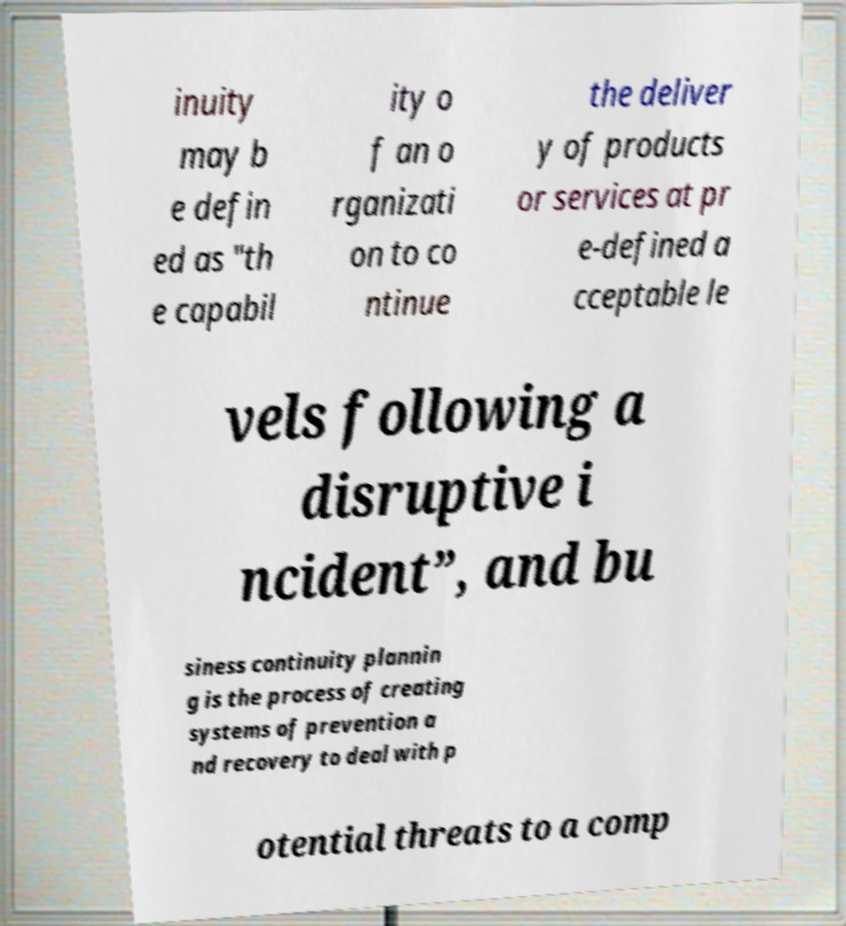Please read and relay the text visible in this image. What does it say? inuity may b e defin ed as "th e capabil ity o f an o rganizati on to co ntinue the deliver y of products or services at pr e-defined a cceptable le vels following a disruptive i ncident”, and bu siness continuity plannin g is the process of creating systems of prevention a nd recovery to deal with p otential threats to a comp 